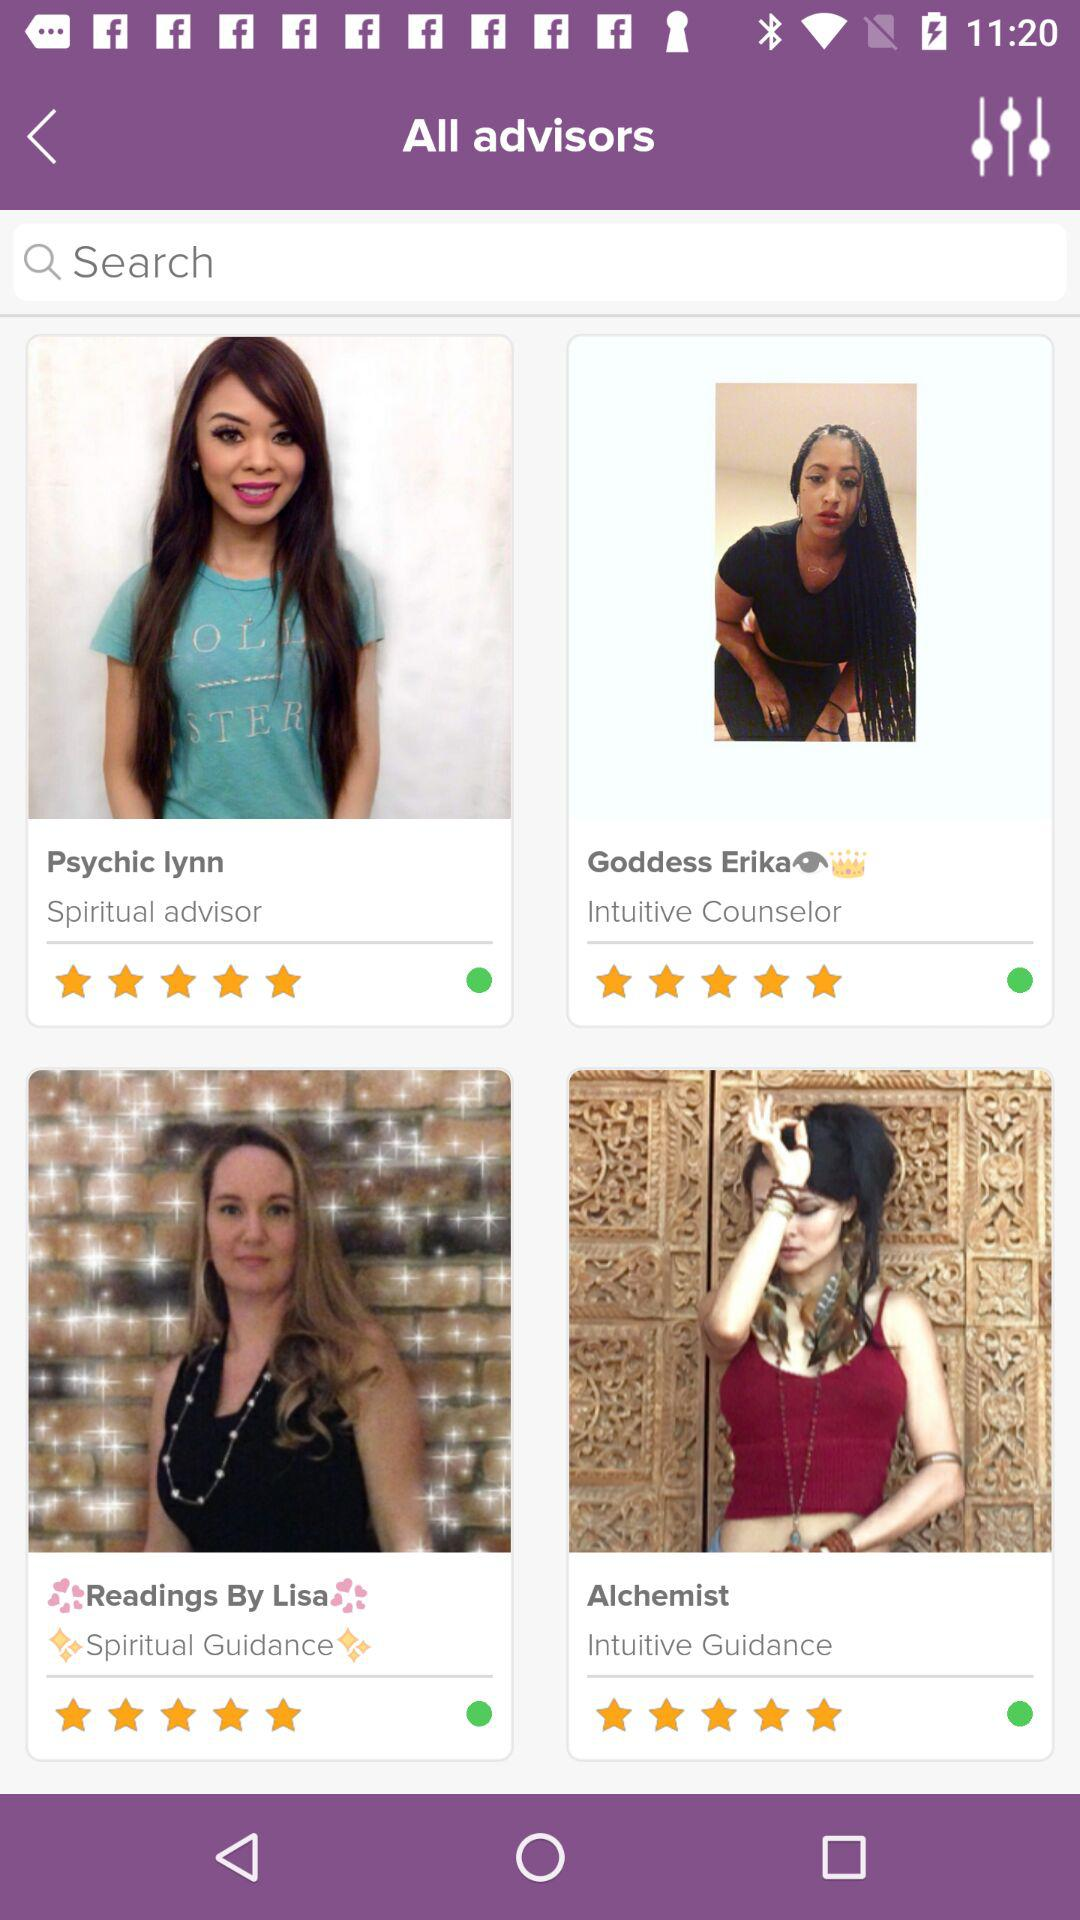What is the star rating of the "Alchemist"? The star rating of the "Alchemist" is 5. 